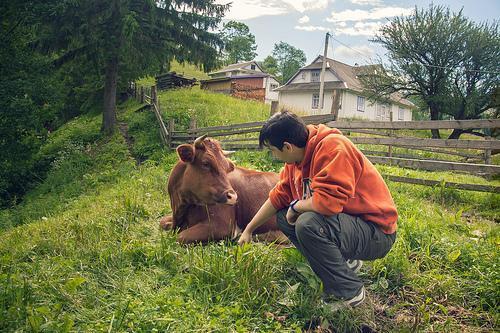How many cows are there?
Give a very brief answer. 1. 